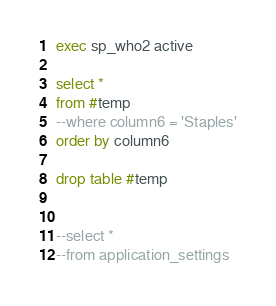<code> <loc_0><loc_0><loc_500><loc_500><_SQL_>exec sp_who2 active

select *
from #temp
--where column6 = 'Staples'
order by column6

drop table #temp


--select *
--from application_settings</code> 